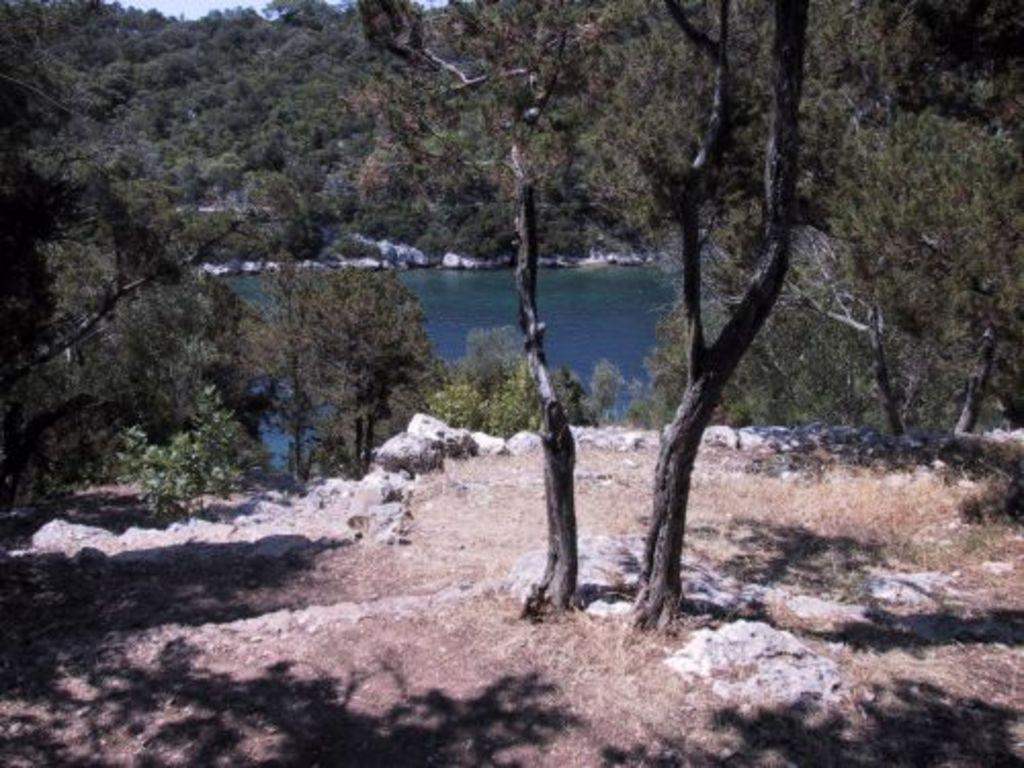What can be seen in the foreground of the image? There is an open area in the foreground of the image. What is visible in the background of the image? There are trees in the background of the image. What is located between the open area and the trees? There is water visible in the image. What songs can be heard playing in the background of the image? There is no indication of any songs playing in the image, as it only shows an open area, trees, and water. Is there any fog visible in the image? There is no mention of fog in the provided facts, and the image does not show any fog. 